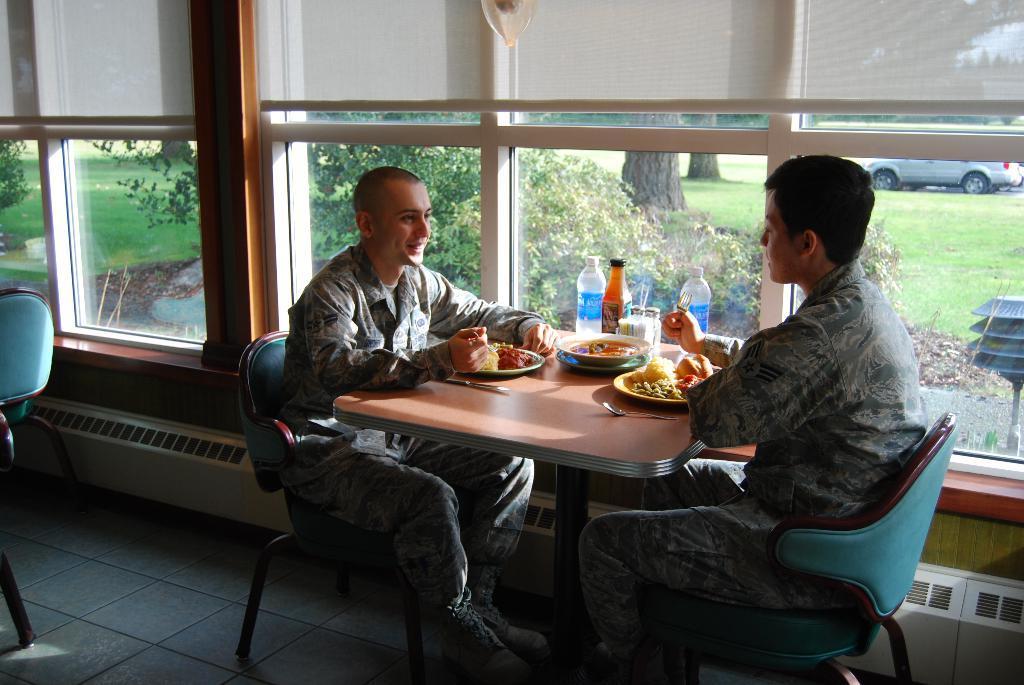Can you describe this image briefly? This picture shows two men seated on the chairs and we see food and water bottles on the table 